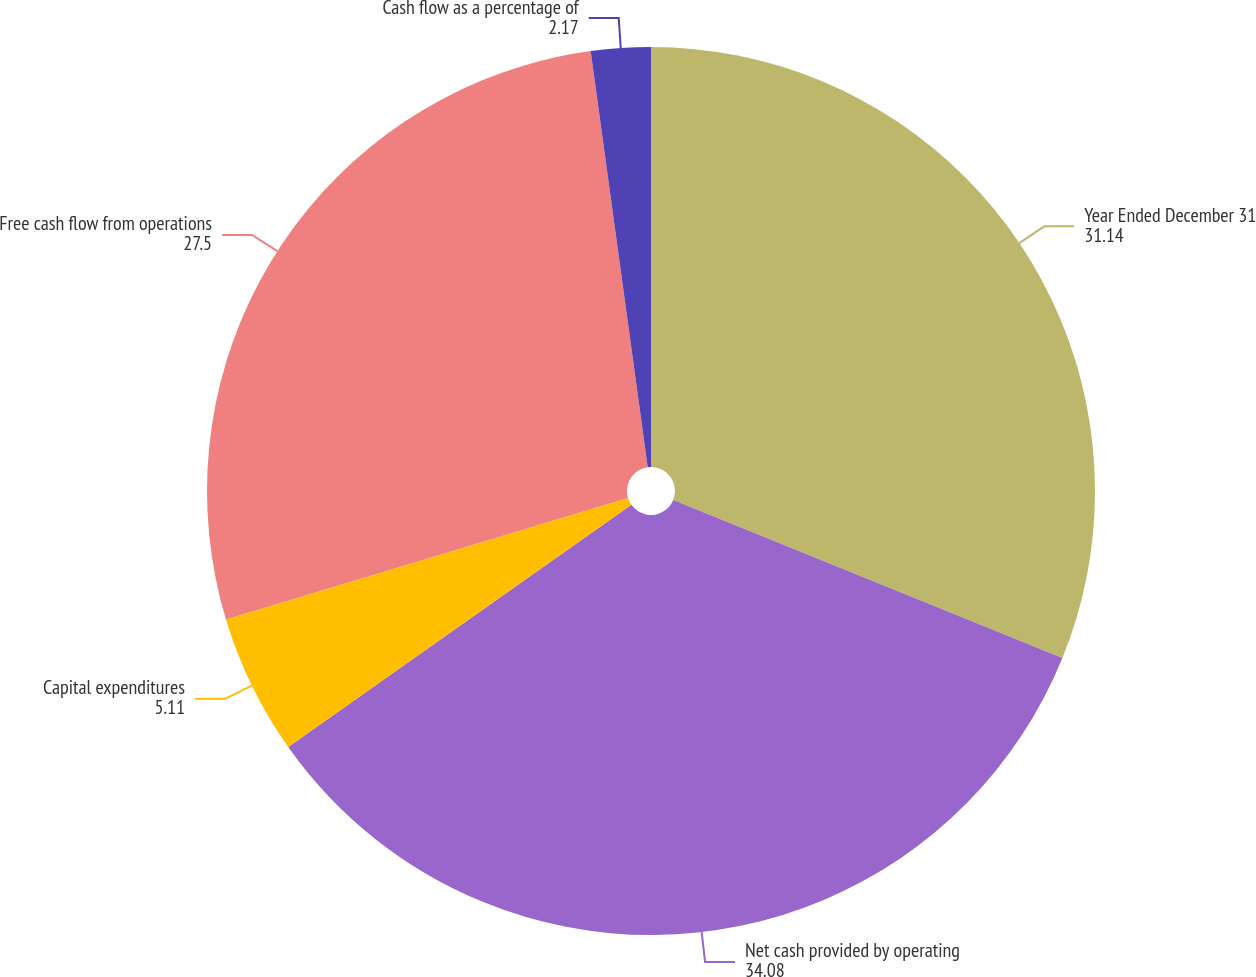Convert chart. <chart><loc_0><loc_0><loc_500><loc_500><pie_chart><fcel>Year Ended December 31<fcel>Net cash provided by operating<fcel>Capital expenditures<fcel>Free cash flow from operations<fcel>Cash flow as a percentage of<nl><fcel>31.14%<fcel>34.08%<fcel>5.11%<fcel>27.5%<fcel>2.17%<nl></chart> 